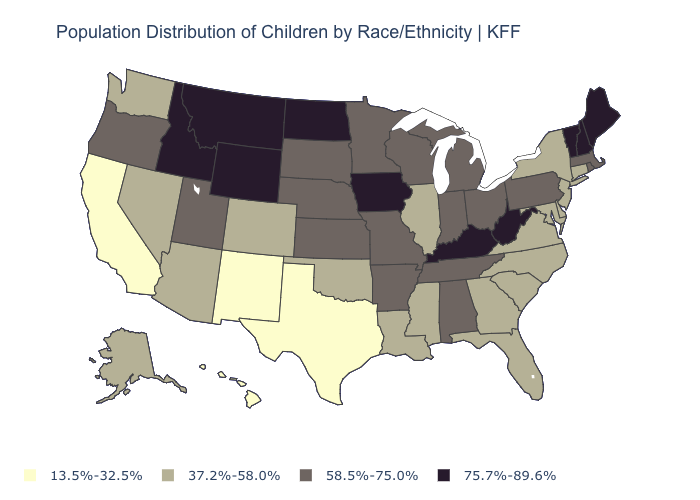Does Arkansas have the highest value in the USA?
Keep it brief. No. How many symbols are there in the legend?
Short answer required. 4. Among the states that border New York , does Vermont have the highest value?
Answer briefly. Yes. Name the states that have a value in the range 75.7%-89.6%?
Short answer required. Idaho, Iowa, Kentucky, Maine, Montana, New Hampshire, North Dakota, Vermont, West Virginia, Wyoming. Does Texas have the lowest value in the USA?
Be succinct. Yes. What is the value of Delaware?
Quick response, please. 37.2%-58.0%. Does Vermont have the same value as Alabama?
Give a very brief answer. No. What is the lowest value in the West?
Be succinct. 13.5%-32.5%. What is the value of New Mexico?
Answer briefly. 13.5%-32.5%. Does Washington have a lower value than Kentucky?
Quick response, please. Yes. Which states have the lowest value in the USA?
Be succinct. California, Hawaii, New Mexico, Texas. Which states have the lowest value in the USA?
Be succinct. California, Hawaii, New Mexico, Texas. Does California have the lowest value in the West?
Write a very short answer. Yes. Name the states that have a value in the range 75.7%-89.6%?
Short answer required. Idaho, Iowa, Kentucky, Maine, Montana, New Hampshire, North Dakota, Vermont, West Virginia, Wyoming. What is the lowest value in the West?
Concise answer only. 13.5%-32.5%. 